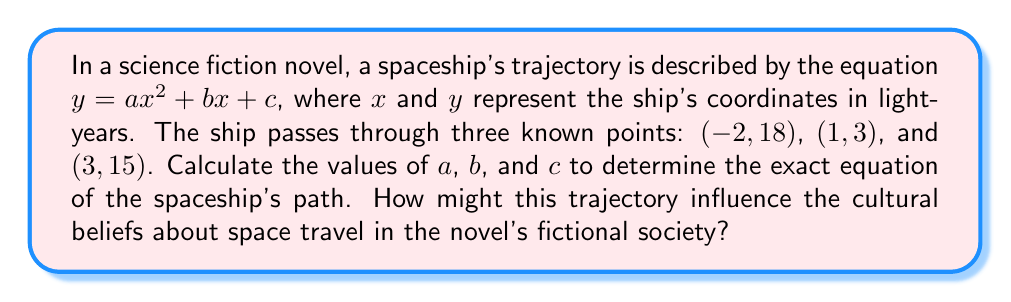Could you help me with this problem? To solve this problem, we'll use the given points to create a system of equations:

1) For $(-2, 18)$: $18 = 4a - 2b + c$
2) For $(1, 3)$: $3 = a + b + c$
3) For $(3, 15)$: $15 = 9a + 3b + c$

Now, let's solve this system of equations:

Step 1: Subtract equation 2 from equation 3:
$12 = 8a + 2b$
$6 = 4a + b$ ... (4)

Step 2: Subtract equation 2 from equation 1:
$15 = 3a - 3b$
$5 = a - b$ ... (5)

Step 3: Add equations 4 and 5:
$11 = 5a$
$a = \frac{11}{5} = 2.2$

Step 4: Substitute $a$ into equation 5:
$5 = 2.2 - b$
$b = -2.8$

Step 5: Substitute $a$ and $b$ into equation 2:
$3 = 2.2 + (-2.8) + c$
$c = 3.6$

Therefore, the equation of the spaceship's trajectory is:

$$y = 2.2x^2 - 2.8x + 3.6$$

This parabolic trajectory might influence cultural beliefs about space travel by:
1. Suggesting that space journeys are not linear, but curved due to gravitational forces.
2. Implying that space travel requires complex calculations and advanced mathematics.
3. Indicating that spacecraft can potentially return to their starting point, fostering ideas of round-trip space exploration.
Answer: $y = 2.2x^2 - 2.8x + 3.6$ 